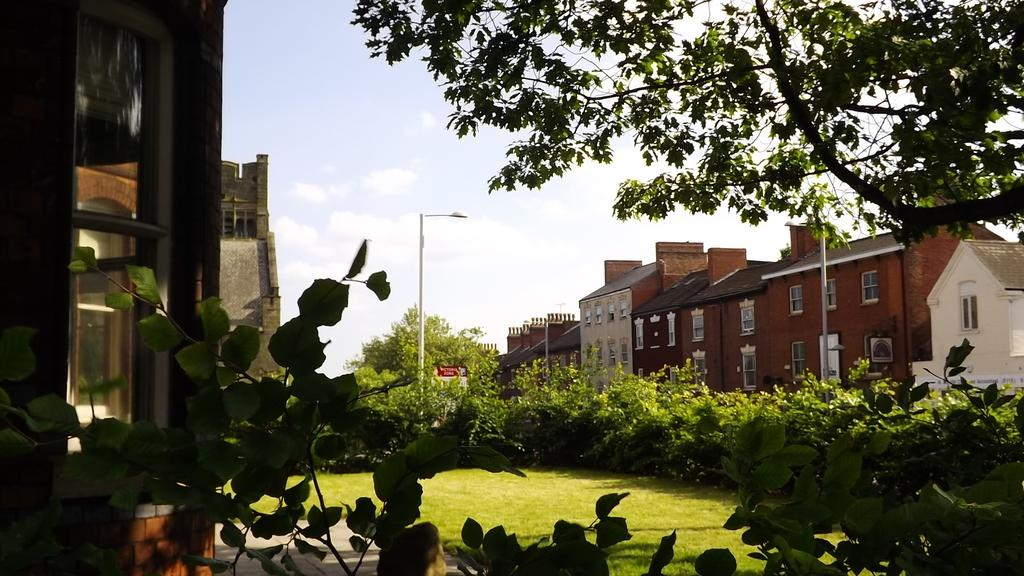What type of structures can be seen in the image? There are houses in the image. What else is present in the image besides houses? There are poles, trees, and grass in the image. What type of comb is used to style the trees in the image? There is no comb present in the image, and the trees are not styled. 